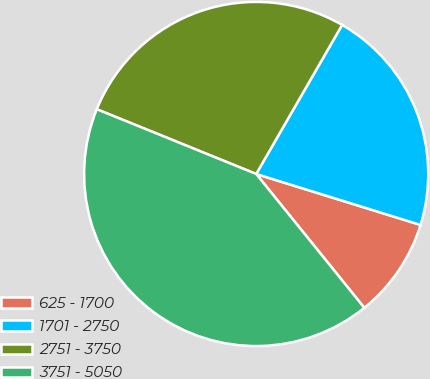<chart> <loc_0><loc_0><loc_500><loc_500><pie_chart><fcel>625 - 1700<fcel>1701 - 2750<fcel>2751 - 3750<fcel>3751 - 5050<nl><fcel>9.4%<fcel>21.46%<fcel>27.18%<fcel>41.95%<nl></chart> 